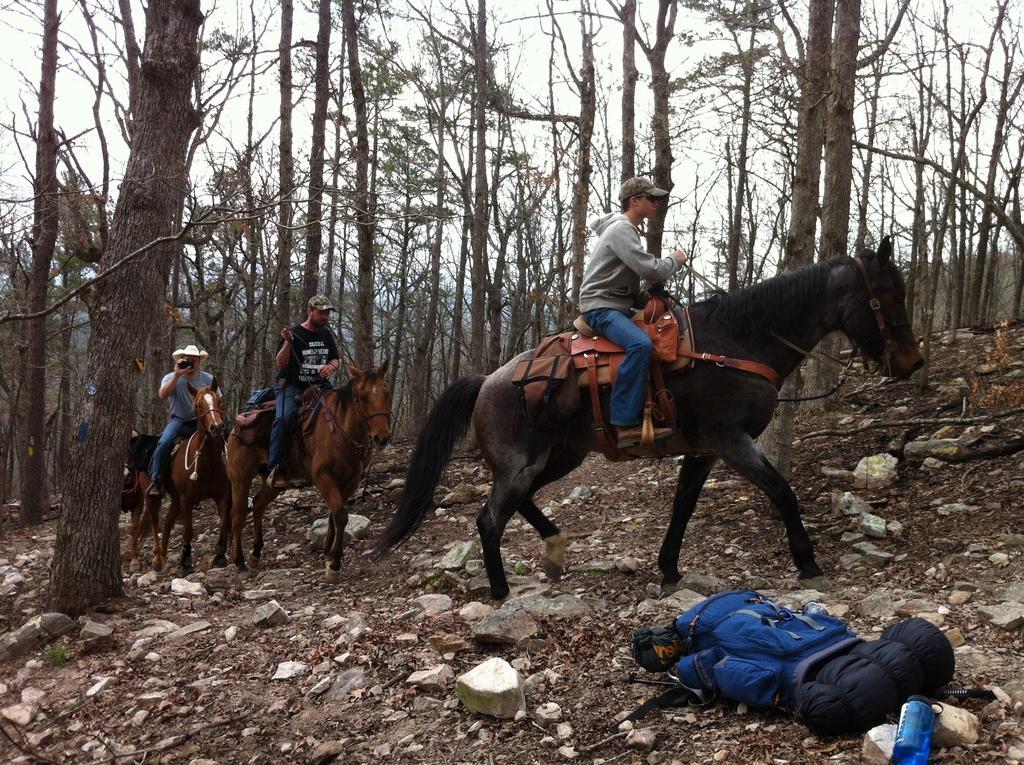Can you describe this image briefly? In the image there are few men riding horses on a rocky land and there are many trees in the background all over the place and above its sky. 